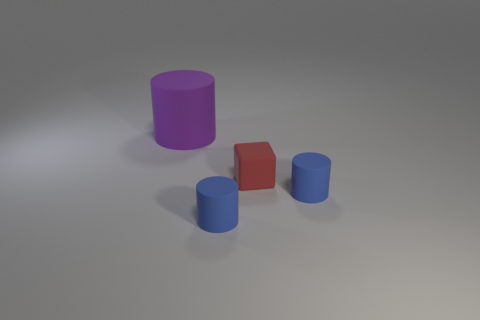What number of tiny objects are to the right of the big rubber cylinder?
Offer a terse response. 3. What number of matte objects are in front of the small red rubber block and on the left side of the small red rubber cube?
Your response must be concise. 1. What number of objects are green metallic objects or tiny rubber things that are in front of the red rubber object?
Ensure brevity in your answer.  2. Are there more large rubber things than small cylinders?
Your answer should be compact. No. What is the shape of the large object that is behind the small red block?
Keep it short and to the point. Cylinder. What number of other matte things have the same shape as the big thing?
Keep it short and to the point. 2. There is a matte object that is to the left of the tiny cylinder that is to the left of the small red thing; what size is it?
Your response must be concise. Large. How many purple objects are either large matte objects or tiny matte cylinders?
Offer a terse response. 1. Is the number of purple rubber cylinders that are behind the big cylinder less than the number of purple cylinders left of the red rubber block?
Your answer should be compact. Yes. There is a red cube; does it have the same size as the rubber thing behind the small red thing?
Your response must be concise. No. 